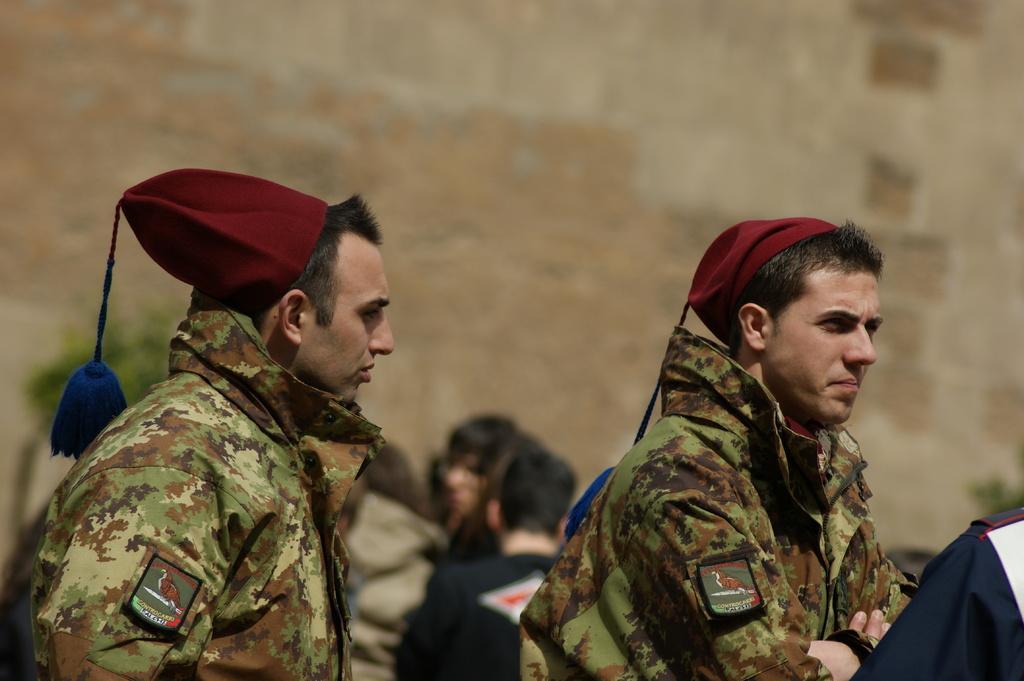Could you give a brief overview of what you see in this image? In this picture we can see two men wearing a cap. There are a few objects visible in the background. Background is blurry. 